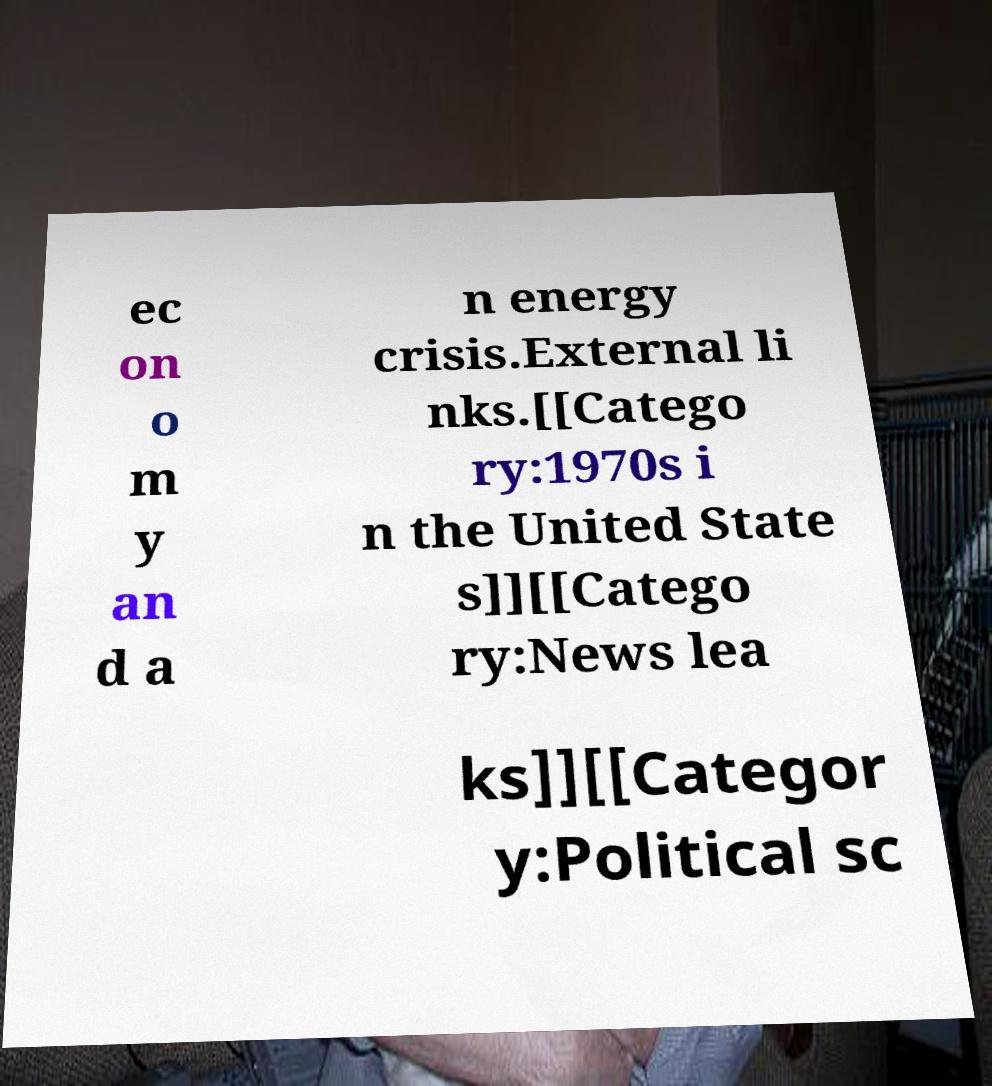Please read and relay the text visible in this image. What does it say? ec on o m y an d a n energy crisis.External li nks.[[Catego ry:1970s i n the United State s]][[Catego ry:News lea ks]][[Categor y:Political sc 